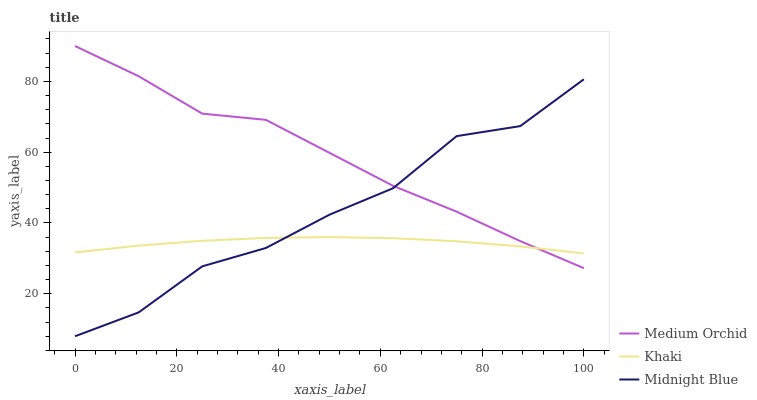Does Khaki have the minimum area under the curve?
Answer yes or no. Yes. Does Medium Orchid have the maximum area under the curve?
Answer yes or no. Yes. Does Midnight Blue have the minimum area under the curve?
Answer yes or no. No. Does Midnight Blue have the maximum area under the curve?
Answer yes or no. No. Is Khaki the smoothest?
Answer yes or no. Yes. Is Midnight Blue the roughest?
Answer yes or no. Yes. Is Midnight Blue the smoothest?
Answer yes or no. No. Is Khaki the roughest?
Answer yes or no. No. Does Khaki have the lowest value?
Answer yes or no. No. Does Medium Orchid have the highest value?
Answer yes or no. Yes. Does Midnight Blue have the highest value?
Answer yes or no. No. 